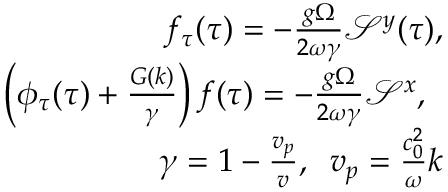<formula> <loc_0><loc_0><loc_500><loc_500>\begin{array} { r l r } & { f _ { \tau } ( \tau ) = - \frac { g \Omega } { 2 \omega \gamma } \mathcal { S } ^ { y } ( \tau ) , } \\ & { \left ( \phi _ { \tau } ( \tau ) + \frac { G ( k ) } { \gamma } \right ) f ( \tau ) = - \frac { g \Omega } { 2 \omega \gamma } \mathcal { S } ^ { x } , \, } \\ & { \gamma = 1 - \frac { v _ { p } } { v } , \, v _ { p } = \frac { c _ { 0 } ^ { 2 } } { \omega } k } \end{array}</formula> 